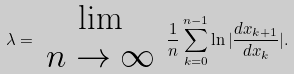Convert formula to latex. <formula><loc_0><loc_0><loc_500><loc_500>\lambda = \begin{array} { c } \lim \\ n \to \infty \\ \end{array} \, \frac { 1 } { n } \sum _ { k = 0 } ^ { n - 1 } \ln | \frac { d x _ { k + 1 } } { d x _ { k } } | .</formula> 